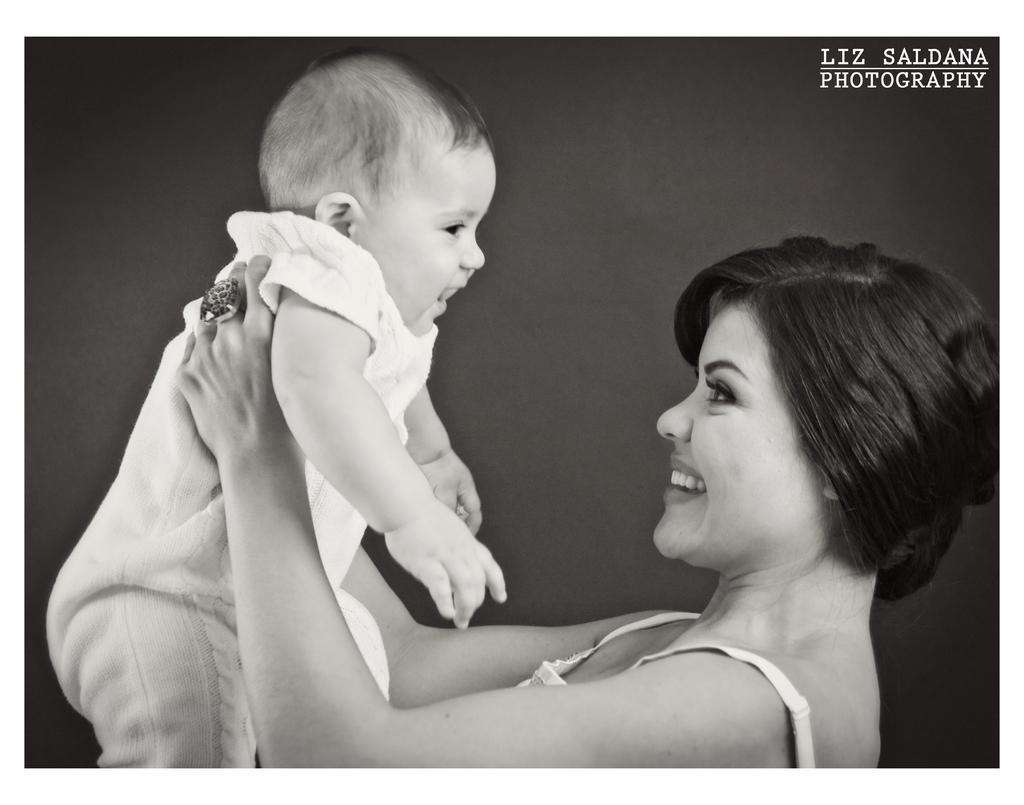Please provide a concise description of this image. In this picture we can see the mother holding the small baby in the hand and smiling. Behind there is a grey background. 